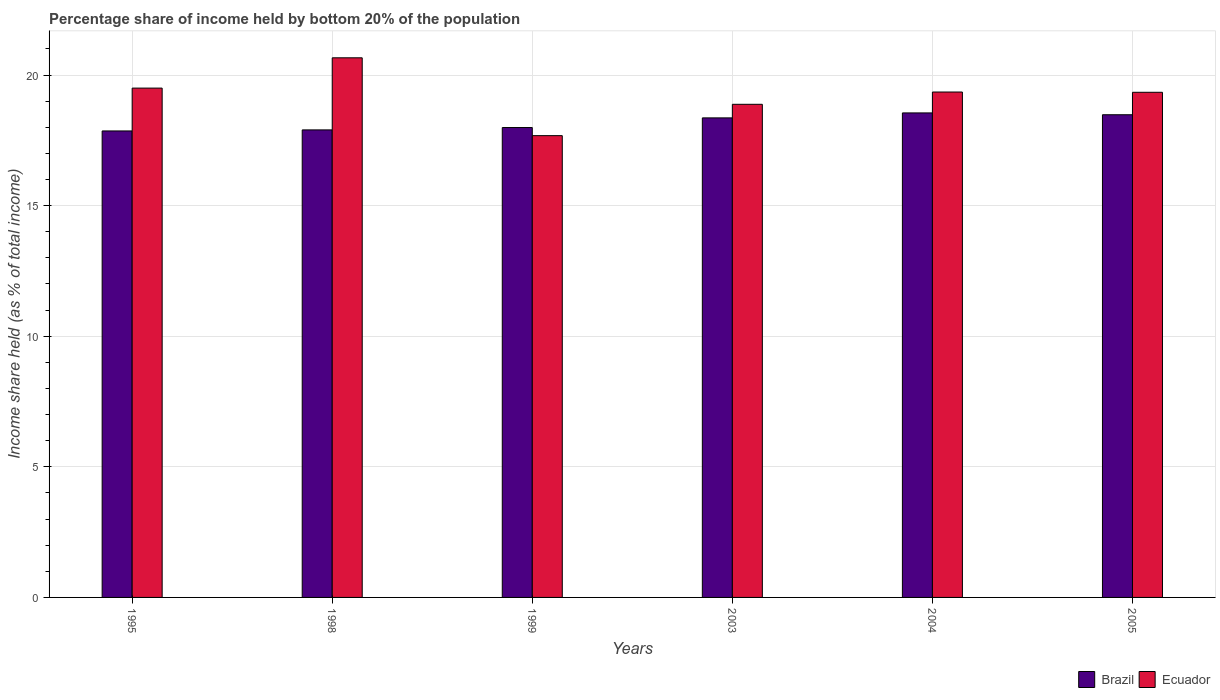Are the number of bars on each tick of the X-axis equal?
Provide a succinct answer. Yes. How many bars are there on the 3rd tick from the left?
Ensure brevity in your answer.  2. What is the label of the 5th group of bars from the left?
Make the answer very short. 2004. In how many cases, is the number of bars for a given year not equal to the number of legend labels?
Offer a very short reply. 0. What is the share of income held by bottom 20% of the population in Ecuador in 1999?
Provide a short and direct response. 17.68. Across all years, what is the maximum share of income held by bottom 20% of the population in Ecuador?
Provide a succinct answer. 20.66. Across all years, what is the minimum share of income held by bottom 20% of the population in Brazil?
Your answer should be very brief. 17.86. In which year was the share of income held by bottom 20% of the population in Ecuador maximum?
Your answer should be compact. 1998. In which year was the share of income held by bottom 20% of the population in Brazil minimum?
Ensure brevity in your answer.  1995. What is the total share of income held by bottom 20% of the population in Brazil in the graph?
Offer a terse response. 109.14. What is the difference between the share of income held by bottom 20% of the population in Brazil in 1995 and that in 1999?
Your answer should be compact. -0.13. What is the difference between the share of income held by bottom 20% of the population in Brazil in 2005 and the share of income held by bottom 20% of the population in Ecuador in 1998?
Offer a very short reply. -2.18. What is the average share of income held by bottom 20% of the population in Brazil per year?
Your response must be concise. 18.19. In the year 2005, what is the difference between the share of income held by bottom 20% of the population in Brazil and share of income held by bottom 20% of the population in Ecuador?
Offer a very short reply. -0.86. In how many years, is the share of income held by bottom 20% of the population in Ecuador greater than 20 %?
Keep it short and to the point. 1. What is the ratio of the share of income held by bottom 20% of the population in Ecuador in 1999 to that in 2003?
Your response must be concise. 0.94. Is the share of income held by bottom 20% of the population in Brazil in 1999 less than that in 2004?
Offer a terse response. Yes. What is the difference between the highest and the second highest share of income held by bottom 20% of the population in Brazil?
Offer a terse response. 0.07. What is the difference between the highest and the lowest share of income held by bottom 20% of the population in Ecuador?
Provide a short and direct response. 2.98. Is the sum of the share of income held by bottom 20% of the population in Ecuador in 1995 and 2004 greater than the maximum share of income held by bottom 20% of the population in Brazil across all years?
Give a very brief answer. Yes. What does the 2nd bar from the left in 1995 represents?
Provide a short and direct response. Ecuador. What does the 2nd bar from the right in 2003 represents?
Give a very brief answer. Brazil. How many bars are there?
Give a very brief answer. 12. Are all the bars in the graph horizontal?
Keep it short and to the point. No. What is the difference between two consecutive major ticks on the Y-axis?
Keep it short and to the point. 5. Are the values on the major ticks of Y-axis written in scientific E-notation?
Make the answer very short. No. Does the graph contain any zero values?
Give a very brief answer. No. Does the graph contain grids?
Keep it short and to the point. Yes. Where does the legend appear in the graph?
Keep it short and to the point. Bottom right. How many legend labels are there?
Provide a short and direct response. 2. What is the title of the graph?
Ensure brevity in your answer.  Percentage share of income held by bottom 20% of the population. What is the label or title of the X-axis?
Give a very brief answer. Years. What is the label or title of the Y-axis?
Give a very brief answer. Income share held (as % of total income). What is the Income share held (as % of total income) in Brazil in 1995?
Offer a terse response. 17.86. What is the Income share held (as % of total income) of Ecuador in 1995?
Give a very brief answer. 19.5. What is the Income share held (as % of total income) of Ecuador in 1998?
Provide a succinct answer. 20.66. What is the Income share held (as % of total income) in Brazil in 1999?
Ensure brevity in your answer.  17.99. What is the Income share held (as % of total income) of Ecuador in 1999?
Provide a succinct answer. 17.68. What is the Income share held (as % of total income) in Brazil in 2003?
Offer a terse response. 18.36. What is the Income share held (as % of total income) of Ecuador in 2003?
Keep it short and to the point. 18.88. What is the Income share held (as % of total income) of Brazil in 2004?
Provide a short and direct response. 18.55. What is the Income share held (as % of total income) of Ecuador in 2004?
Provide a succinct answer. 19.35. What is the Income share held (as % of total income) in Brazil in 2005?
Offer a very short reply. 18.48. What is the Income share held (as % of total income) in Ecuador in 2005?
Your answer should be compact. 19.34. Across all years, what is the maximum Income share held (as % of total income) in Brazil?
Keep it short and to the point. 18.55. Across all years, what is the maximum Income share held (as % of total income) in Ecuador?
Provide a succinct answer. 20.66. Across all years, what is the minimum Income share held (as % of total income) in Brazil?
Provide a succinct answer. 17.86. Across all years, what is the minimum Income share held (as % of total income) of Ecuador?
Offer a very short reply. 17.68. What is the total Income share held (as % of total income) of Brazil in the graph?
Provide a short and direct response. 109.14. What is the total Income share held (as % of total income) in Ecuador in the graph?
Offer a terse response. 115.41. What is the difference between the Income share held (as % of total income) in Brazil in 1995 and that in 1998?
Your answer should be very brief. -0.04. What is the difference between the Income share held (as % of total income) in Ecuador in 1995 and that in 1998?
Your answer should be compact. -1.16. What is the difference between the Income share held (as % of total income) of Brazil in 1995 and that in 1999?
Your answer should be very brief. -0.13. What is the difference between the Income share held (as % of total income) of Ecuador in 1995 and that in 1999?
Provide a short and direct response. 1.82. What is the difference between the Income share held (as % of total income) of Ecuador in 1995 and that in 2003?
Provide a succinct answer. 0.62. What is the difference between the Income share held (as % of total income) in Brazil in 1995 and that in 2004?
Offer a terse response. -0.69. What is the difference between the Income share held (as % of total income) of Ecuador in 1995 and that in 2004?
Ensure brevity in your answer.  0.15. What is the difference between the Income share held (as % of total income) of Brazil in 1995 and that in 2005?
Your answer should be compact. -0.62. What is the difference between the Income share held (as % of total income) of Ecuador in 1995 and that in 2005?
Keep it short and to the point. 0.16. What is the difference between the Income share held (as % of total income) in Brazil in 1998 and that in 1999?
Provide a succinct answer. -0.09. What is the difference between the Income share held (as % of total income) in Ecuador in 1998 and that in 1999?
Offer a very short reply. 2.98. What is the difference between the Income share held (as % of total income) of Brazil in 1998 and that in 2003?
Provide a succinct answer. -0.46. What is the difference between the Income share held (as % of total income) of Ecuador in 1998 and that in 2003?
Your answer should be compact. 1.78. What is the difference between the Income share held (as % of total income) in Brazil in 1998 and that in 2004?
Your answer should be compact. -0.65. What is the difference between the Income share held (as % of total income) in Ecuador in 1998 and that in 2004?
Ensure brevity in your answer.  1.31. What is the difference between the Income share held (as % of total income) of Brazil in 1998 and that in 2005?
Provide a short and direct response. -0.58. What is the difference between the Income share held (as % of total income) of Ecuador in 1998 and that in 2005?
Your answer should be very brief. 1.32. What is the difference between the Income share held (as % of total income) in Brazil in 1999 and that in 2003?
Your answer should be very brief. -0.37. What is the difference between the Income share held (as % of total income) of Brazil in 1999 and that in 2004?
Provide a succinct answer. -0.56. What is the difference between the Income share held (as % of total income) of Ecuador in 1999 and that in 2004?
Provide a short and direct response. -1.67. What is the difference between the Income share held (as % of total income) in Brazil in 1999 and that in 2005?
Give a very brief answer. -0.49. What is the difference between the Income share held (as % of total income) of Ecuador in 1999 and that in 2005?
Offer a very short reply. -1.66. What is the difference between the Income share held (as % of total income) of Brazil in 2003 and that in 2004?
Offer a terse response. -0.19. What is the difference between the Income share held (as % of total income) of Ecuador in 2003 and that in 2004?
Give a very brief answer. -0.47. What is the difference between the Income share held (as % of total income) of Brazil in 2003 and that in 2005?
Your answer should be very brief. -0.12. What is the difference between the Income share held (as % of total income) of Ecuador in 2003 and that in 2005?
Your response must be concise. -0.46. What is the difference between the Income share held (as % of total income) in Brazil in 2004 and that in 2005?
Your answer should be very brief. 0.07. What is the difference between the Income share held (as % of total income) in Ecuador in 2004 and that in 2005?
Your answer should be very brief. 0.01. What is the difference between the Income share held (as % of total income) of Brazil in 1995 and the Income share held (as % of total income) of Ecuador in 1999?
Keep it short and to the point. 0.18. What is the difference between the Income share held (as % of total income) of Brazil in 1995 and the Income share held (as % of total income) of Ecuador in 2003?
Make the answer very short. -1.02. What is the difference between the Income share held (as % of total income) of Brazil in 1995 and the Income share held (as % of total income) of Ecuador in 2004?
Your answer should be compact. -1.49. What is the difference between the Income share held (as % of total income) of Brazil in 1995 and the Income share held (as % of total income) of Ecuador in 2005?
Ensure brevity in your answer.  -1.48. What is the difference between the Income share held (as % of total income) in Brazil in 1998 and the Income share held (as % of total income) in Ecuador in 1999?
Make the answer very short. 0.22. What is the difference between the Income share held (as % of total income) of Brazil in 1998 and the Income share held (as % of total income) of Ecuador in 2003?
Offer a very short reply. -0.98. What is the difference between the Income share held (as % of total income) of Brazil in 1998 and the Income share held (as % of total income) of Ecuador in 2004?
Provide a succinct answer. -1.45. What is the difference between the Income share held (as % of total income) of Brazil in 1998 and the Income share held (as % of total income) of Ecuador in 2005?
Give a very brief answer. -1.44. What is the difference between the Income share held (as % of total income) in Brazil in 1999 and the Income share held (as % of total income) in Ecuador in 2003?
Your answer should be very brief. -0.89. What is the difference between the Income share held (as % of total income) in Brazil in 1999 and the Income share held (as % of total income) in Ecuador in 2004?
Your response must be concise. -1.36. What is the difference between the Income share held (as % of total income) of Brazil in 1999 and the Income share held (as % of total income) of Ecuador in 2005?
Offer a very short reply. -1.35. What is the difference between the Income share held (as % of total income) in Brazil in 2003 and the Income share held (as % of total income) in Ecuador in 2004?
Make the answer very short. -0.99. What is the difference between the Income share held (as % of total income) in Brazil in 2003 and the Income share held (as % of total income) in Ecuador in 2005?
Ensure brevity in your answer.  -0.98. What is the difference between the Income share held (as % of total income) in Brazil in 2004 and the Income share held (as % of total income) in Ecuador in 2005?
Offer a terse response. -0.79. What is the average Income share held (as % of total income) of Brazil per year?
Provide a short and direct response. 18.19. What is the average Income share held (as % of total income) in Ecuador per year?
Your answer should be compact. 19.23. In the year 1995, what is the difference between the Income share held (as % of total income) of Brazil and Income share held (as % of total income) of Ecuador?
Provide a short and direct response. -1.64. In the year 1998, what is the difference between the Income share held (as % of total income) in Brazil and Income share held (as % of total income) in Ecuador?
Provide a succinct answer. -2.76. In the year 1999, what is the difference between the Income share held (as % of total income) in Brazil and Income share held (as % of total income) in Ecuador?
Offer a very short reply. 0.31. In the year 2003, what is the difference between the Income share held (as % of total income) in Brazil and Income share held (as % of total income) in Ecuador?
Your answer should be compact. -0.52. In the year 2004, what is the difference between the Income share held (as % of total income) of Brazil and Income share held (as % of total income) of Ecuador?
Keep it short and to the point. -0.8. In the year 2005, what is the difference between the Income share held (as % of total income) of Brazil and Income share held (as % of total income) of Ecuador?
Provide a short and direct response. -0.86. What is the ratio of the Income share held (as % of total income) of Brazil in 1995 to that in 1998?
Your answer should be very brief. 1. What is the ratio of the Income share held (as % of total income) of Ecuador in 1995 to that in 1998?
Make the answer very short. 0.94. What is the ratio of the Income share held (as % of total income) in Ecuador in 1995 to that in 1999?
Ensure brevity in your answer.  1.1. What is the ratio of the Income share held (as % of total income) of Brazil in 1995 to that in 2003?
Ensure brevity in your answer.  0.97. What is the ratio of the Income share held (as % of total income) in Ecuador in 1995 to that in 2003?
Provide a short and direct response. 1.03. What is the ratio of the Income share held (as % of total income) in Brazil in 1995 to that in 2004?
Your answer should be compact. 0.96. What is the ratio of the Income share held (as % of total income) in Ecuador in 1995 to that in 2004?
Your answer should be very brief. 1.01. What is the ratio of the Income share held (as % of total income) of Brazil in 1995 to that in 2005?
Ensure brevity in your answer.  0.97. What is the ratio of the Income share held (as % of total income) of Ecuador in 1995 to that in 2005?
Give a very brief answer. 1.01. What is the ratio of the Income share held (as % of total income) in Brazil in 1998 to that in 1999?
Give a very brief answer. 0.99. What is the ratio of the Income share held (as % of total income) of Ecuador in 1998 to that in 1999?
Offer a very short reply. 1.17. What is the ratio of the Income share held (as % of total income) in Brazil in 1998 to that in 2003?
Offer a terse response. 0.97. What is the ratio of the Income share held (as % of total income) of Ecuador in 1998 to that in 2003?
Your response must be concise. 1.09. What is the ratio of the Income share held (as % of total income) of Brazil in 1998 to that in 2004?
Provide a succinct answer. 0.96. What is the ratio of the Income share held (as % of total income) in Ecuador in 1998 to that in 2004?
Give a very brief answer. 1.07. What is the ratio of the Income share held (as % of total income) of Brazil in 1998 to that in 2005?
Provide a succinct answer. 0.97. What is the ratio of the Income share held (as % of total income) of Ecuador in 1998 to that in 2005?
Offer a terse response. 1.07. What is the ratio of the Income share held (as % of total income) of Brazil in 1999 to that in 2003?
Provide a short and direct response. 0.98. What is the ratio of the Income share held (as % of total income) in Ecuador in 1999 to that in 2003?
Make the answer very short. 0.94. What is the ratio of the Income share held (as % of total income) in Brazil in 1999 to that in 2004?
Give a very brief answer. 0.97. What is the ratio of the Income share held (as % of total income) of Ecuador in 1999 to that in 2004?
Provide a succinct answer. 0.91. What is the ratio of the Income share held (as % of total income) of Brazil in 1999 to that in 2005?
Give a very brief answer. 0.97. What is the ratio of the Income share held (as % of total income) of Ecuador in 1999 to that in 2005?
Offer a terse response. 0.91. What is the ratio of the Income share held (as % of total income) in Ecuador in 2003 to that in 2004?
Make the answer very short. 0.98. What is the ratio of the Income share held (as % of total income) of Ecuador in 2003 to that in 2005?
Give a very brief answer. 0.98. What is the difference between the highest and the second highest Income share held (as % of total income) in Brazil?
Provide a succinct answer. 0.07. What is the difference between the highest and the second highest Income share held (as % of total income) in Ecuador?
Your answer should be very brief. 1.16. What is the difference between the highest and the lowest Income share held (as % of total income) of Brazil?
Offer a very short reply. 0.69. What is the difference between the highest and the lowest Income share held (as % of total income) in Ecuador?
Make the answer very short. 2.98. 